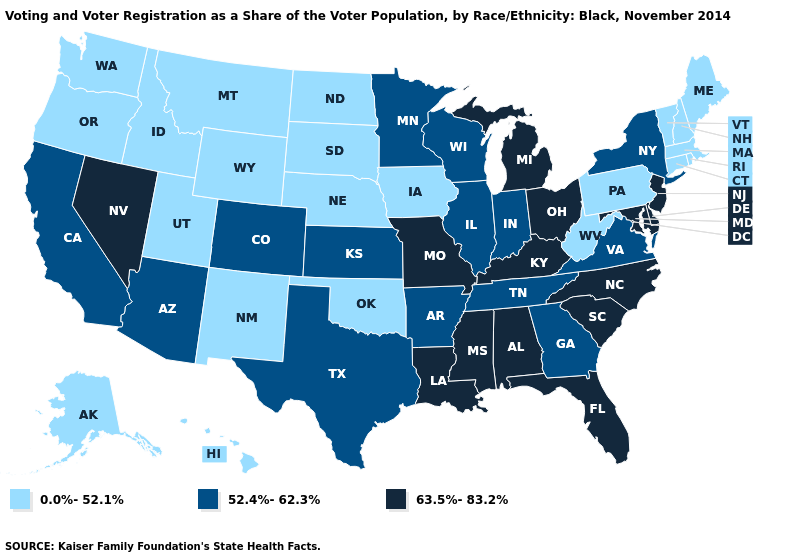Among the states that border Illinois , which have the lowest value?
Be succinct. Iowa. What is the value of New Mexico?
Short answer required. 0.0%-52.1%. Which states have the lowest value in the MidWest?
Answer briefly. Iowa, Nebraska, North Dakota, South Dakota. Name the states that have a value in the range 52.4%-62.3%?
Give a very brief answer. Arizona, Arkansas, California, Colorado, Georgia, Illinois, Indiana, Kansas, Minnesota, New York, Tennessee, Texas, Virginia, Wisconsin. What is the lowest value in states that border Oklahoma?
Be succinct. 0.0%-52.1%. Does New Mexico have the lowest value in the USA?
Quick response, please. Yes. Name the states that have a value in the range 63.5%-83.2%?
Concise answer only. Alabama, Delaware, Florida, Kentucky, Louisiana, Maryland, Michigan, Mississippi, Missouri, Nevada, New Jersey, North Carolina, Ohio, South Carolina. What is the value of Pennsylvania?
Keep it brief. 0.0%-52.1%. Does Arizona have the highest value in the USA?
Write a very short answer. No. Does Michigan have a higher value than Idaho?
Quick response, please. Yes. Which states hav the highest value in the West?
Give a very brief answer. Nevada. Which states have the lowest value in the USA?
Quick response, please. Alaska, Connecticut, Hawaii, Idaho, Iowa, Maine, Massachusetts, Montana, Nebraska, New Hampshire, New Mexico, North Dakota, Oklahoma, Oregon, Pennsylvania, Rhode Island, South Dakota, Utah, Vermont, Washington, West Virginia, Wyoming. Does Washington have the highest value in the USA?
Quick response, please. No. Which states have the lowest value in the South?
Answer briefly. Oklahoma, West Virginia. 